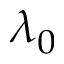Convert formula to latex. <formula><loc_0><loc_0><loc_500><loc_500>\lambda _ { 0 }</formula> 